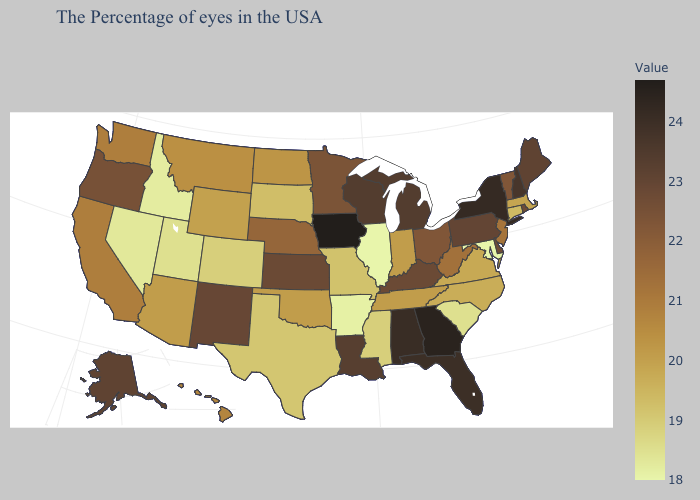Does West Virginia have a lower value than Vermont?
Concise answer only. Yes. Which states hav the highest value in the West?
Short answer required. Alaska. Does Rhode Island have the highest value in the USA?
Keep it brief. No. Does Iowa have the highest value in the MidWest?
Be succinct. Yes. Which states hav the highest value in the South?
Answer briefly. Georgia. 